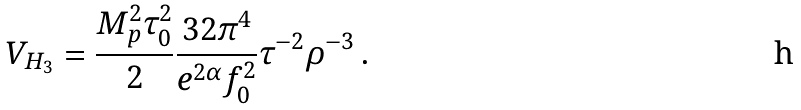<formula> <loc_0><loc_0><loc_500><loc_500>V _ { H _ { 3 } } = \frac { M _ { p } ^ { 2 } \tau _ { 0 } ^ { 2 } } { 2 } \frac { 3 2 \pi ^ { 4 } } { e ^ { 2 \alpha } f _ { 0 } ^ { 2 } } \tau ^ { - 2 } \rho ^ { - 3 } \, .</formula> 